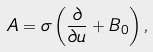Convert formula to latex. <formula><loc_0><loc_0><loc_500><loc_500>A = \sigma \left ( \frac { \partial } { \partial u } + B _ { 0 } \right ) ,</formula> 